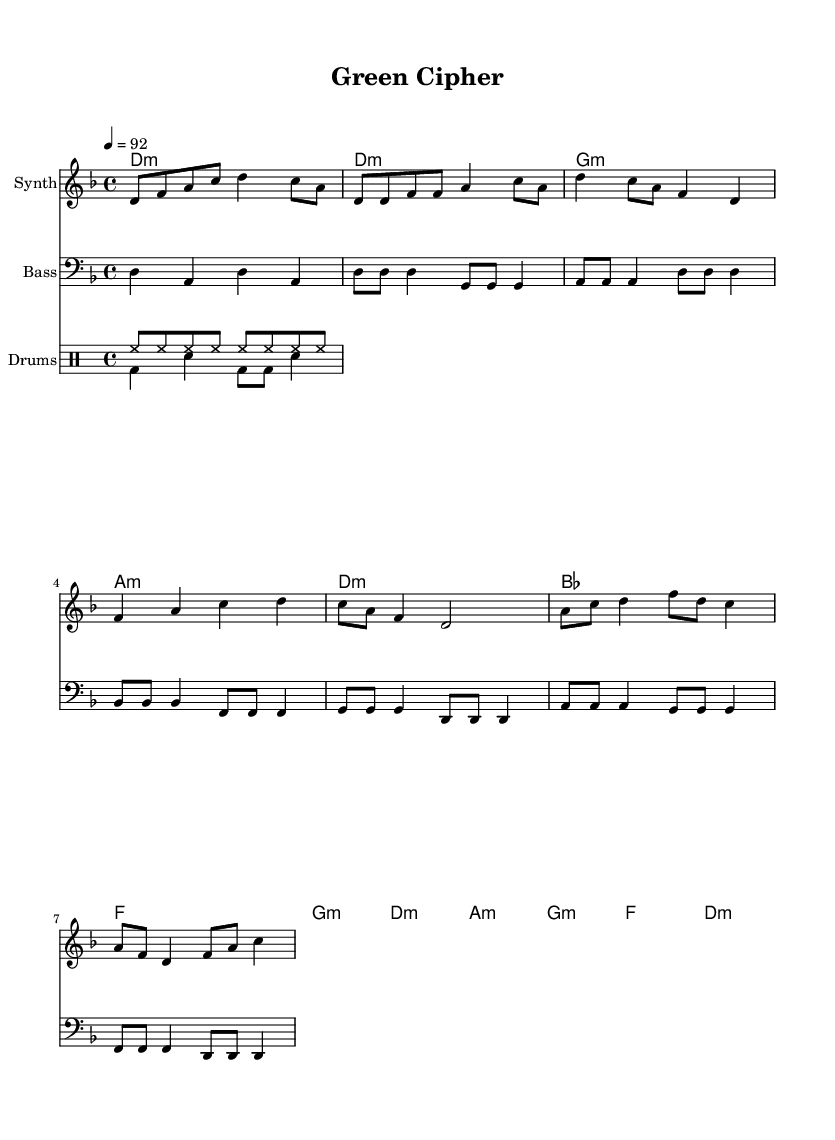What is the key signature of this music? The key signature is two flats, which indicates D minor. This can be identified from the key signature mark placed at the beginning of the sheet music.
Answer: D minor What is the time signature of this music? The time signature is 4/4, as indicated at the beginning of the sheet music. This means there are four beats in each measure, and each quarter note is a beat.
Answer: 4/4 What is the tempo marking for the music? The tempo marking "4 = 92" indicates that there are 92 beats per minute. This tempo is found in the header section of the sheet music.
Answer: 92 How many measures are in the verse section? The verse section contains 4 measures. This can be deduced by counting the measures in the verse patterns provided in the melody and bassline segments.
Answer: 4 What chord follows the D minor in the verse? The chord that follows D minor is G minor. This is found by analyzing the chord progression in the verse section, which shows the sequence of chords after D minor.
Answer: G minor What is the structure of the song? The structure includes an Intro, Verse, Chorus, and Bridge. This is identified by labels within the sheet music that indicate the sections clearly.
Answer: Intro, Verse, Chorus, Bridge What two instruments are primarily featured in this piece? The primary instruments featured are synth and bass. This is noted from the staff labels at the beginning of each instrument's section in the score.
Answer: Synth and Bass 